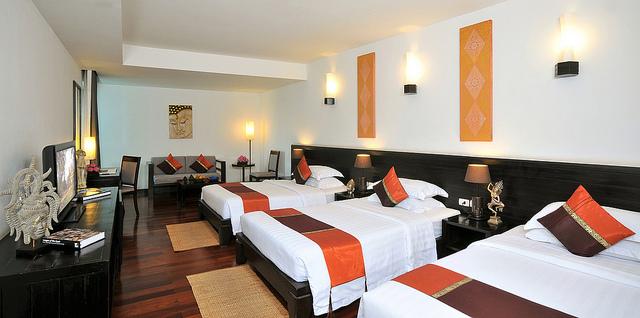How many lights are there?
Be succinct. 8. Do the beds have the same bedding and pillows?
Answer briefly. Yes. How many pillows are there?
Concise answer only. 11. 